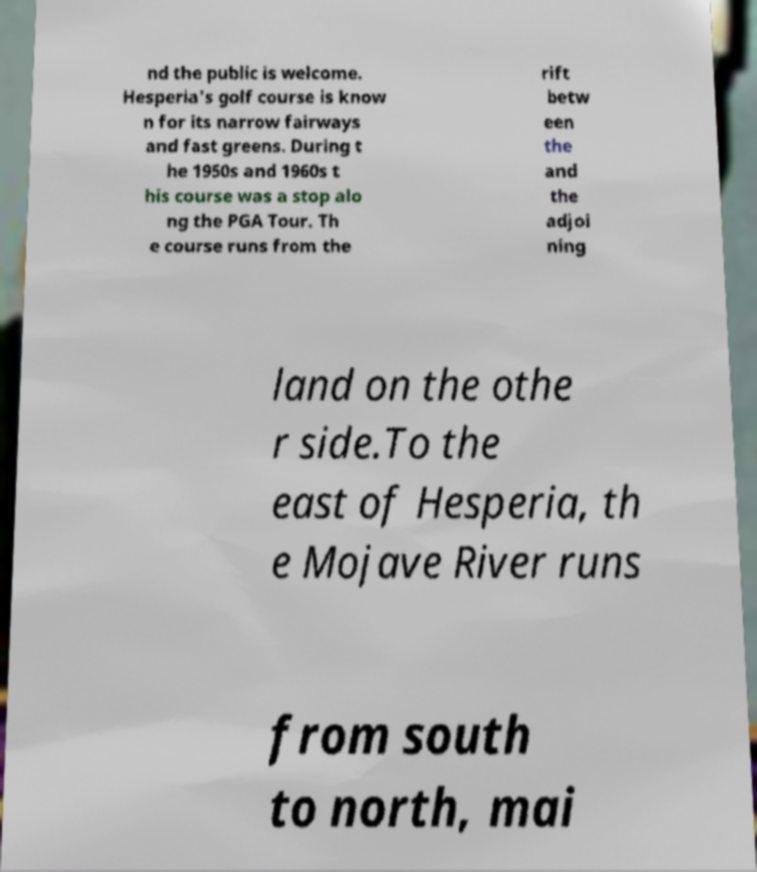There's text embedded in this image that I need extracted. Can you transcribe it verbatim? nd the public is welcome. Hesperia's golf course is know n for its narrow fairways and fast greens. During t he 1950s and 1960s t his course was a stop alo ng the PGA Tour. Th e course runs from the rift betw een the and the adjoi ning land on the othe r side.To the east of Hesperia, th e Mojave River runs from south to north, mai 